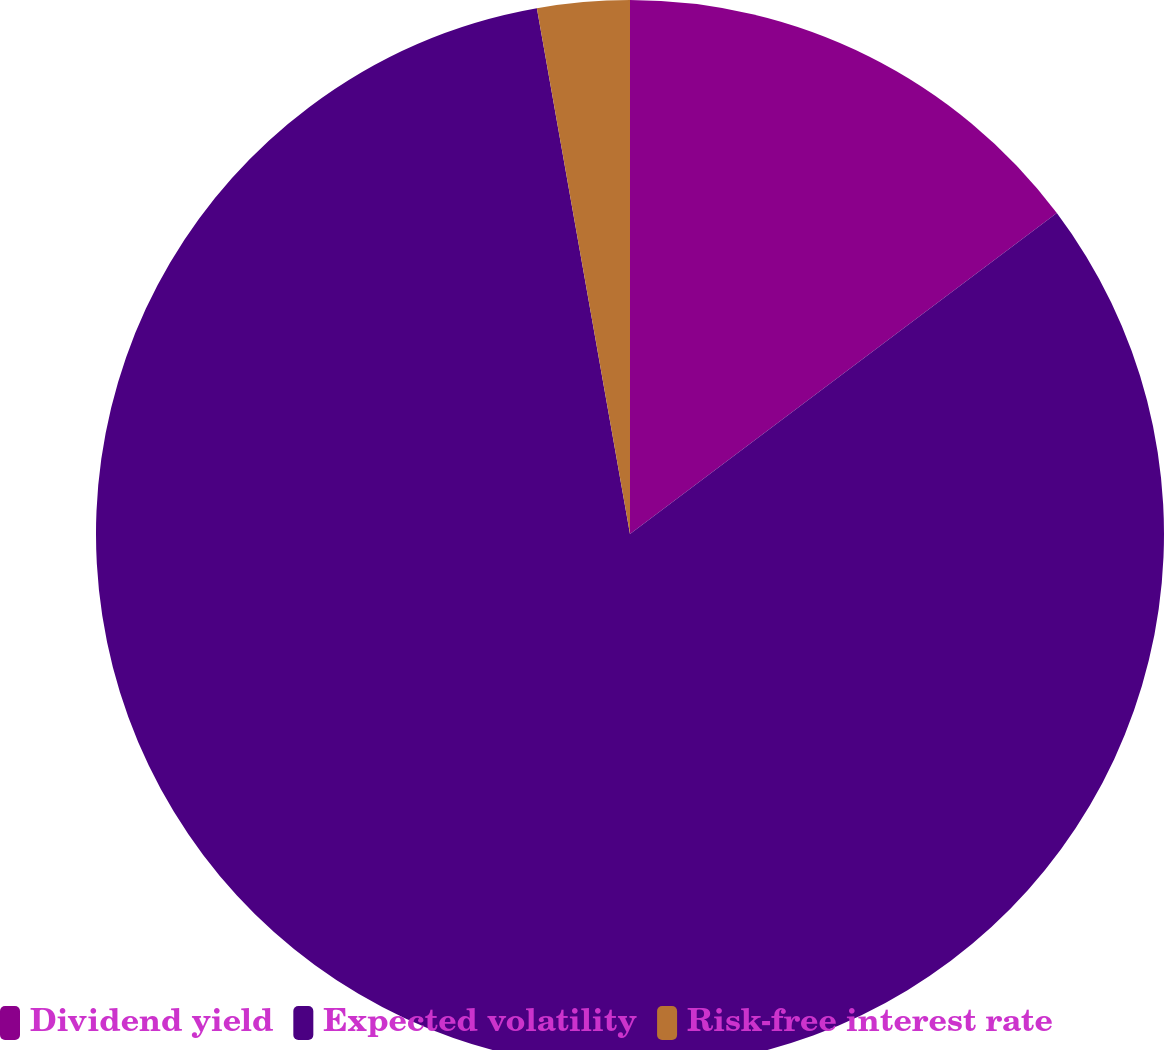Convert chart to OTSL. <chart><loc_0><loc_0><loc_500><loc_500><pie_chart><fcel>Dividend yield<fcel>Expected volatility<fcel>Risk-free interest rate<nl><fcel>14.74%<fcel>82.47%<fcel>2.79%<nl></chart> 